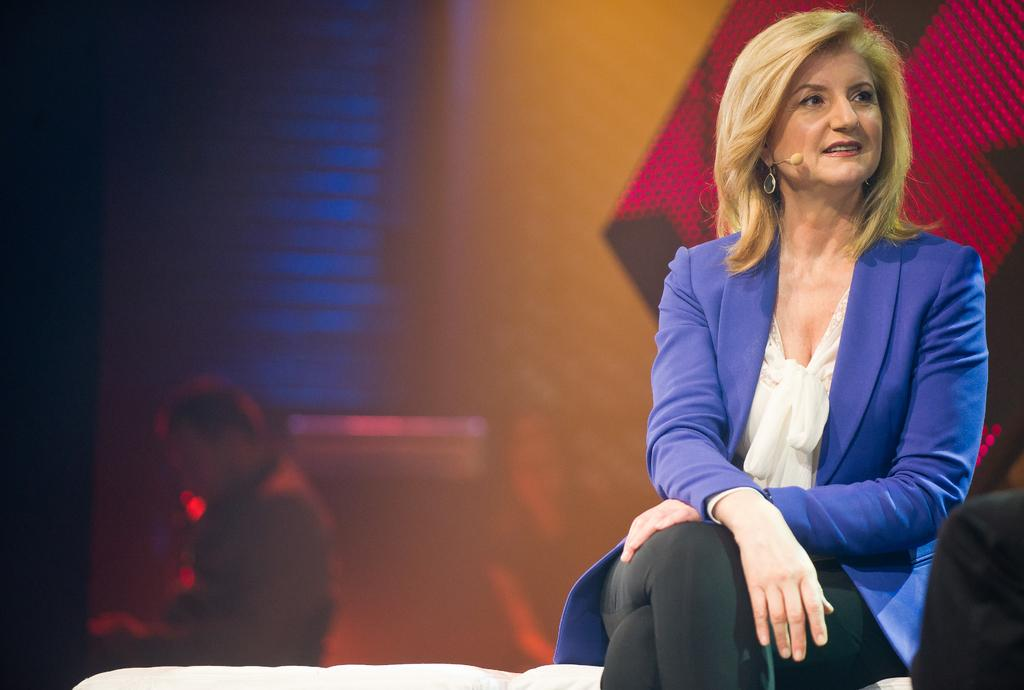What is the lady in the image doing? The lady is sitting in the image. What is the lady wearing in the image? The lady is wearing a mic and earrings in the image. Can you describe the person in the background of the image? The person in the background of the image is blurred, so it is difficult to provide a detailed description. What type of jar can be seen near the sea in the image? There is no jar or sea present in the image; it features a lady sitting with a mic and earrings. Is there a tent visible in the image? There is no tent present in the image. 